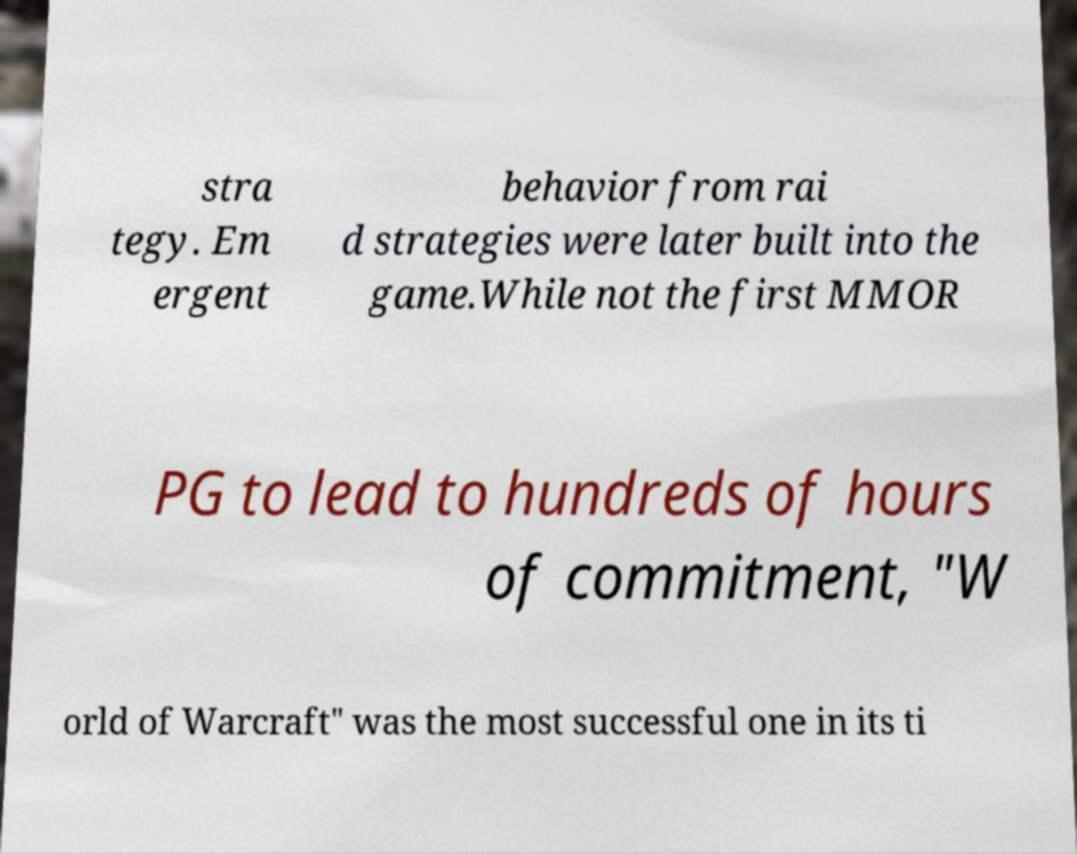Please read and relay the text visible in this image. What does it say? stra tegy. Em ergent behavior from rai d strategies were later built into the game.While not the first MMOR PG to lead to hundreds of hours of commitment, "W orld of Warcraft" was the most successful one in its ti 